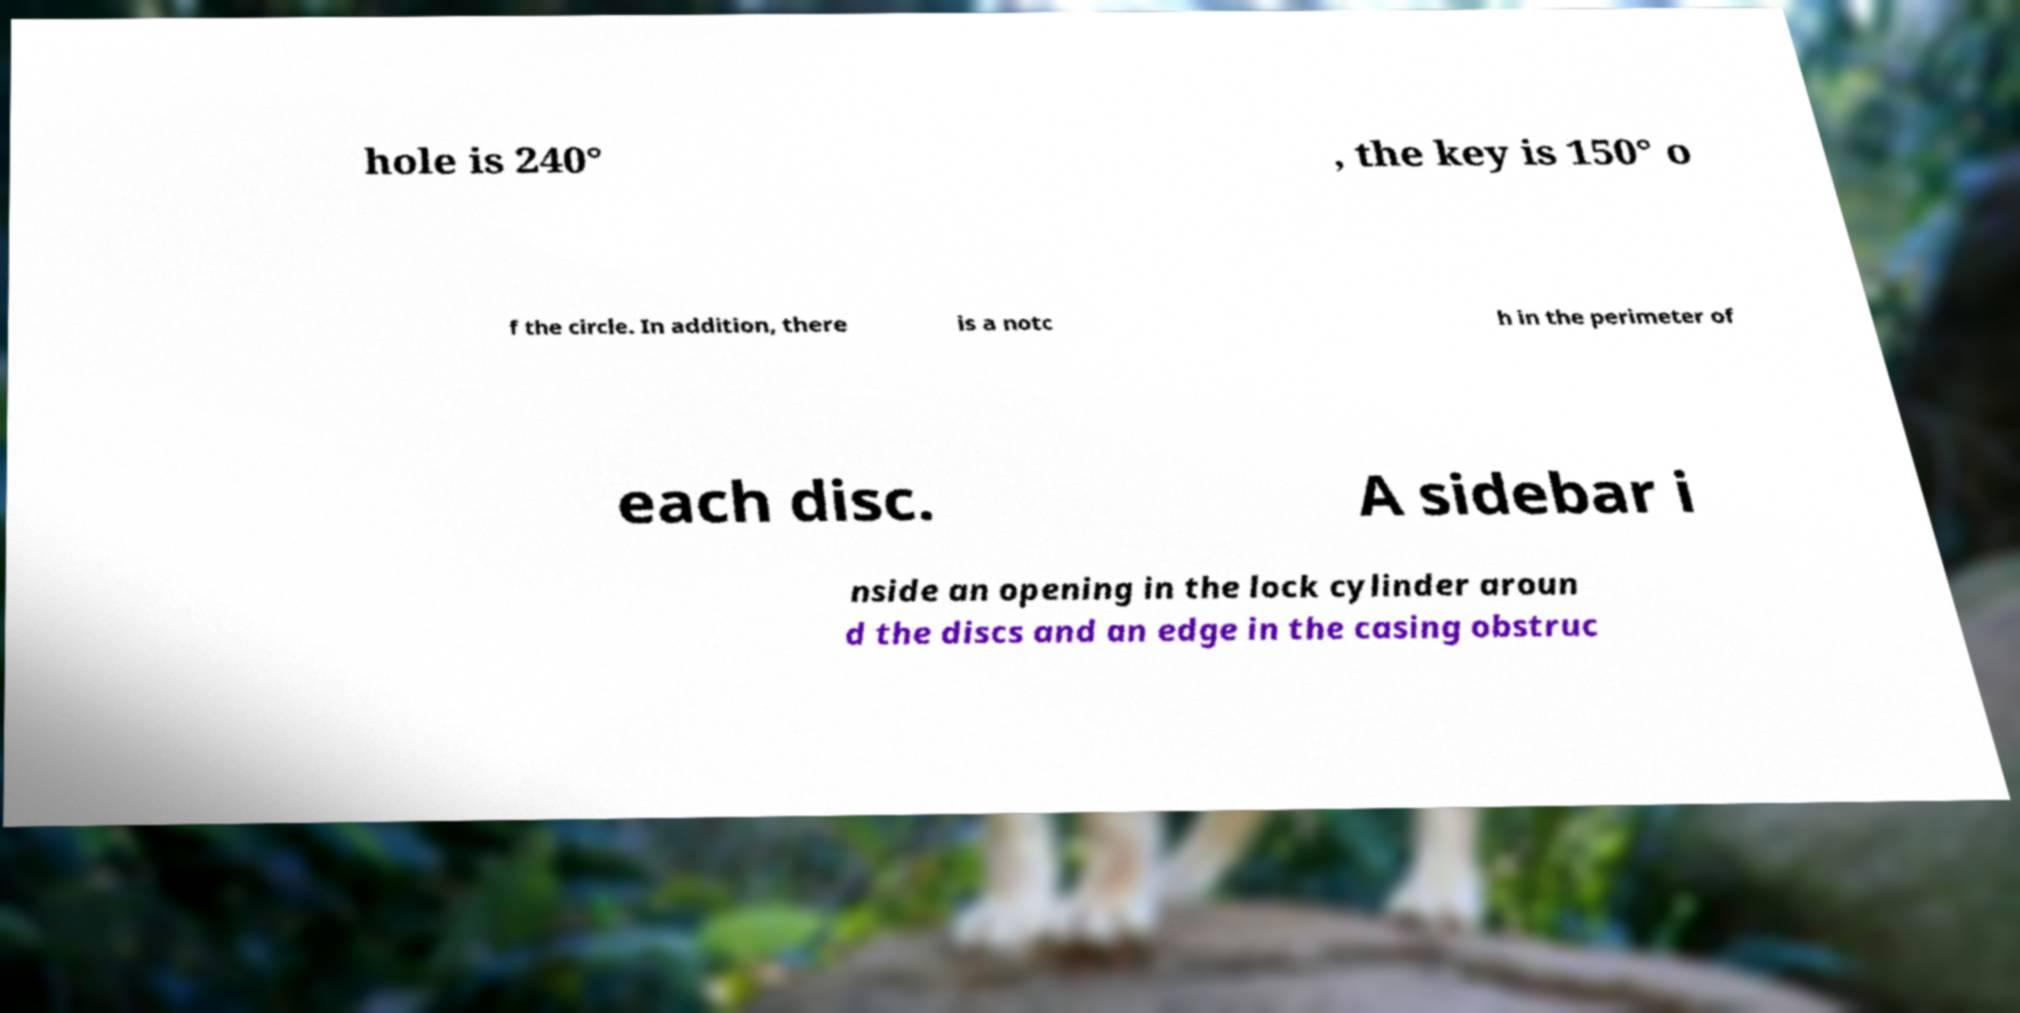Can you accurately transcribe the text from the provided image for me? hole is 240° , the key is 150° o f the circle. In addition, there is a notc h in the perimeter of each disc. A sidebar i nside an opening in the lock cylinder aroun d the discs and an edge in the casing obstruc 